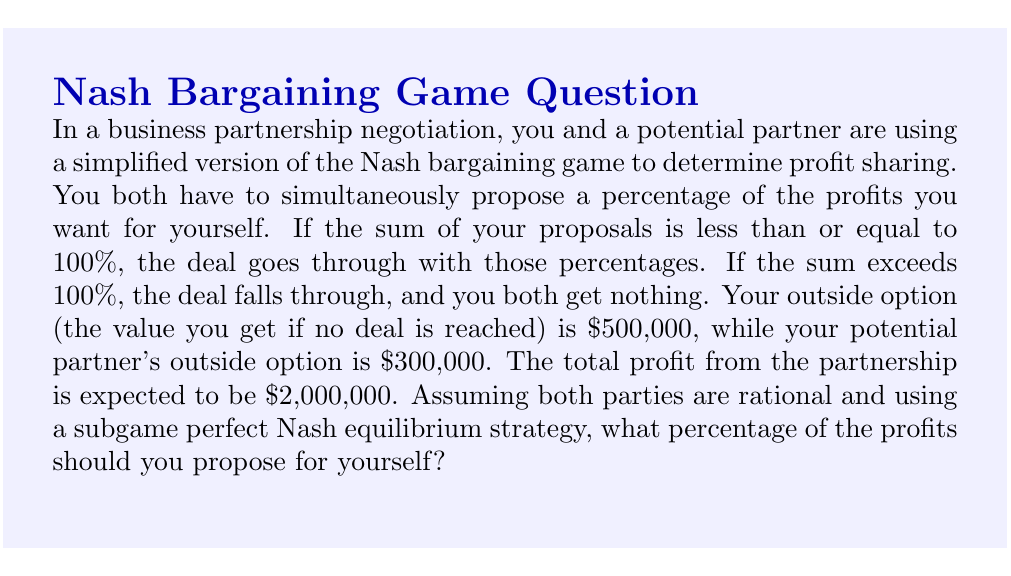What is the answer to this math problem? To solve this problem, we'll use the concept of Nash bargaining solution and subgame perfect Nash equilibrium:

1) First, let's define the variables:
   $x$ = Your proposed share of the profits
   $y$ = Your partner's proposed share of the profits

2) The total available profit is $2,000,000. Your outside option is $500,000, and your partner's is $300,000.

3) For a deal to be reached, we need:
   $x + y \leq 1$ (as percentages should sum to 100% or less)

4) The Nash bargaining solution maximizes the product of the gains from cooperation:
   $\max [(2,000,000x - 500,000)(2,000,000y - 300,000)]$

5) Taking the derivative with respect to $x$ and setting it to zero:
   $\frac{d}{dx}[(2,000,000x - 500,000)(2,000,000y - 300,000)] = 0$
   $2,000,000(2,000,000y - 300,000) - 2,000,000(2,000,000x - 500,000) = 0$

6) Simplifying and solving for $y$:
   $y = x - 0.1$

7) Substituting this back into the constraint $x + y = 1$:
   $x + (x - 0.1) = 1$
   $2x = 1.1$
   $x = 0.55$

8) Therefore, you should propose 55% for yourself, leaving 45% for your partner.

9) We can verify this is a subgame perfect Nash equilibrium:
   - If you propose more than 55%, your partner's best response would make the total exceed 100%, causing the deal to fall through.
   - If you propose less than 55%, you're leaving money on the table that your partner would claim.
Answer: You should propose 55% of the profits for yourself. 